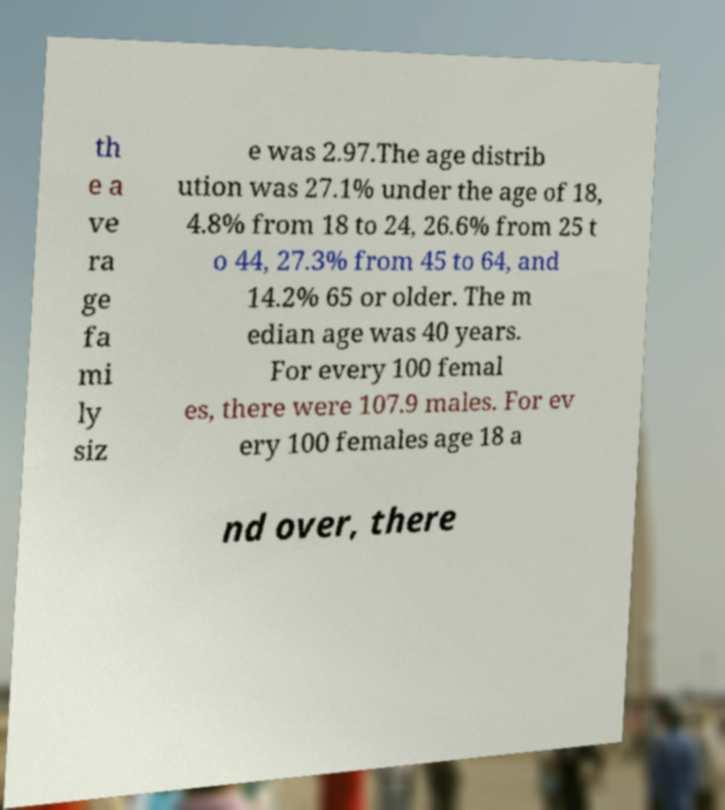Could you extract and type out the text from this image? th e a ve ra ge fa mi ly siz e was 2.97.The age distrib ution was 27.1% under the age of 18, 4.8% from 18 to 24, 26.6% from 25 t o 44, 27.3% from 45 to 64, and 14.2% 65 or older. The m edian age was 40 years. For every 100 femal es, there were 107.9 males. For ev ery 100 females age 18 a nd over, there 